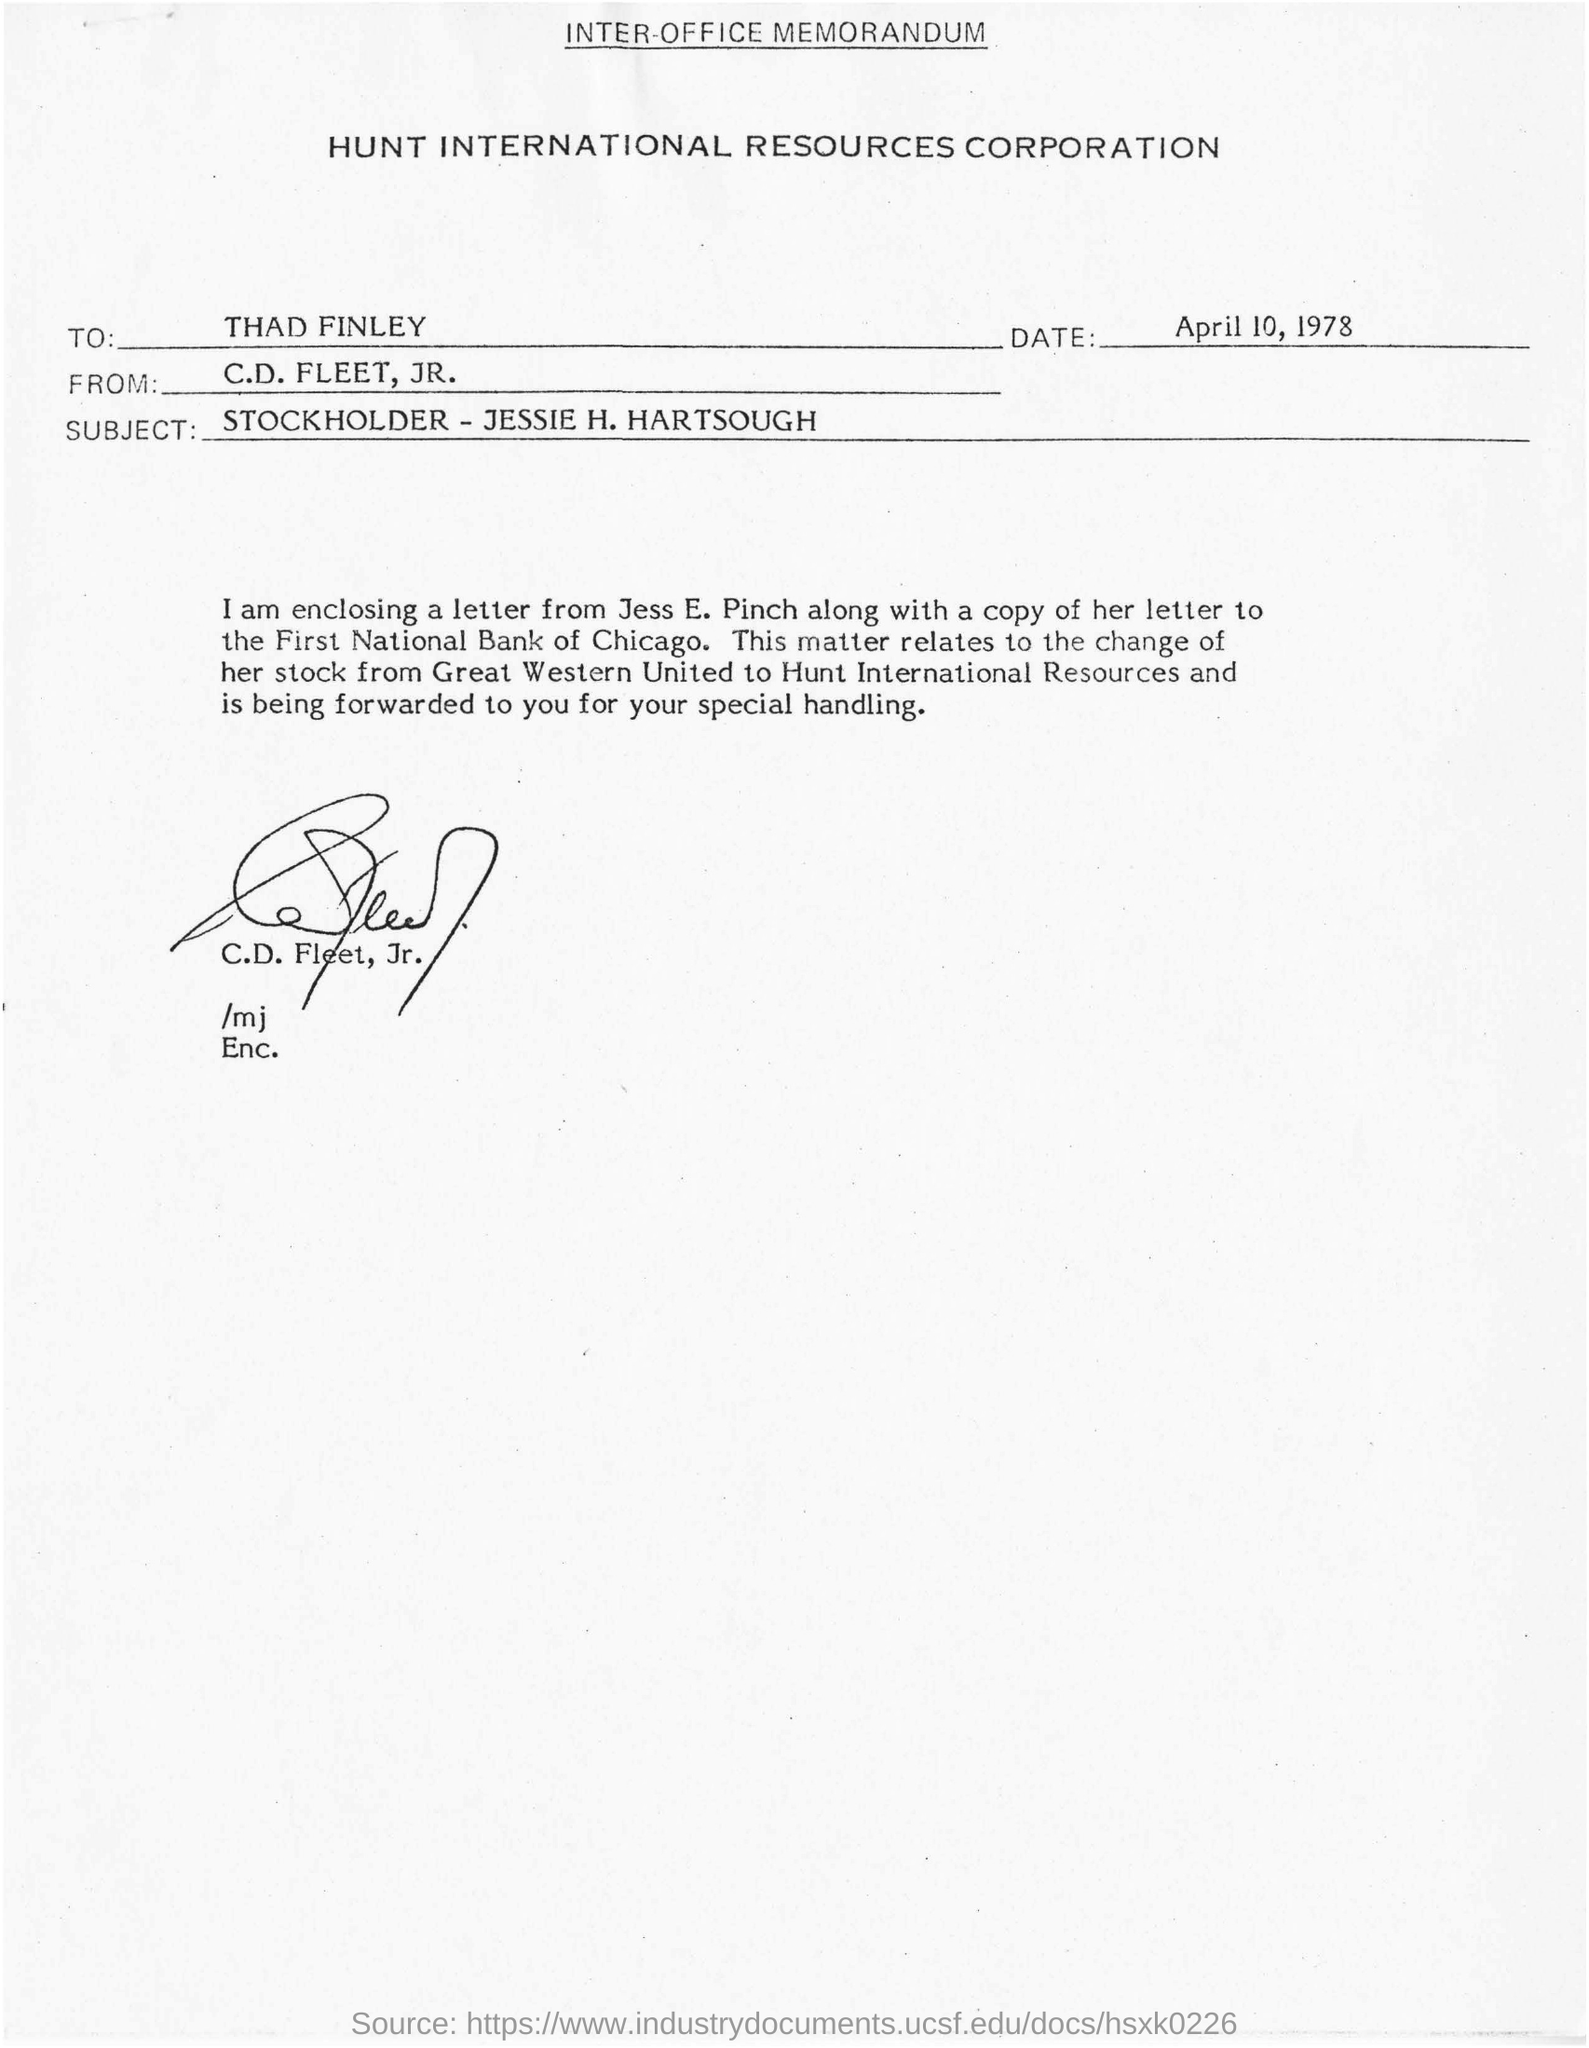What is the name of the corporation mentioned ?
Your answer should be compact. Hunt International Resources Corporation. What is the date mentioned in the given page ?
Your answer should be very brief. April 10, 1978. To whom the memorandum was written ?
Provide a succinct answer. THAD FINLEY. From whom the memorandum was sent ?
Your answer should be very brief. C.d. fleet, jr. What is the subject mentioned ?
Your answer should be very brief. Stockholder - jessie h. hartsough. Who's sign was there at the bottom of the letter ?
Keep it short and to the point. C.d. fleet, jr. 